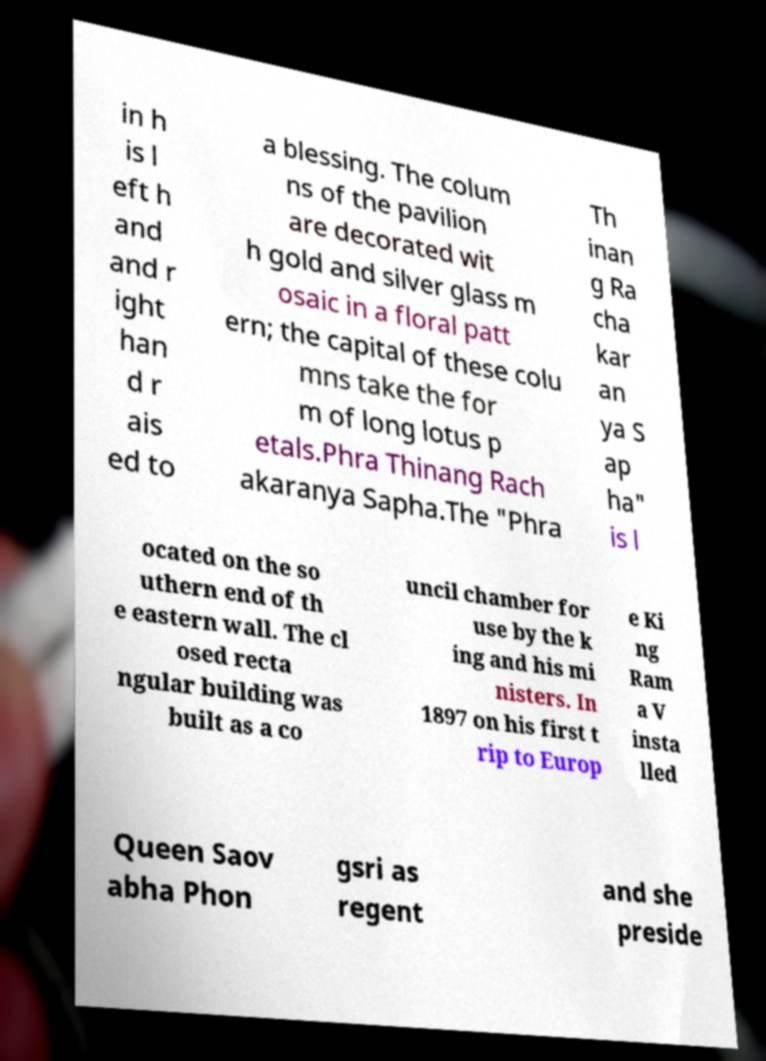I need the written content from this picture converted into text. Can you do that? in h is l eft h and and r ight han d r ais ed to a blessing. The colum ns of the pavilion are decorated wit h gold and silver glass m osaic in a floral patt ern; the capital of these colu mns take the for m of long lotus p etals.Phra Thinang Rach akaranya Sapha.The "Phra Th inan g Ra cha kar an ya S ap ha" is l ocated on the so uthern end of th e eastern wall. The cl osed recta ngular building was built as a co uncil chamber for use by the k ing and his mi nisters. In 1897 on his first t rip to Europ e Ki ng Ram a V insta lled Queen Saov abha Phon gsri as regent and she preside 